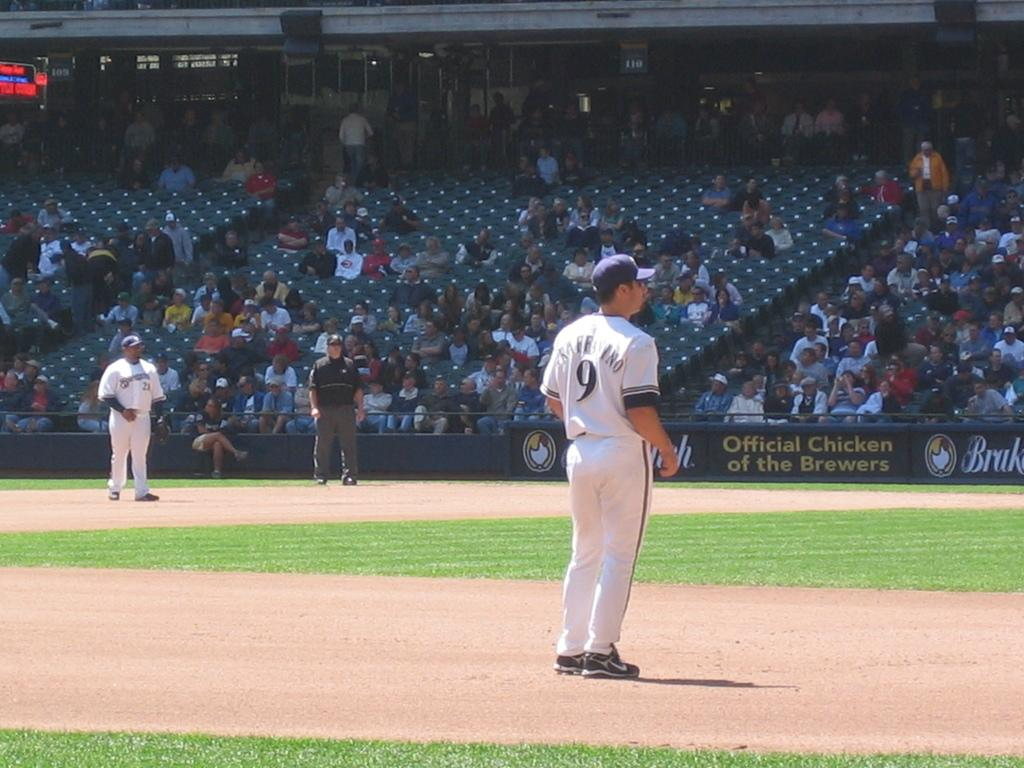<image>
Provide a brief description of the given image. During a baseball game number 9 is standing in the infield. 